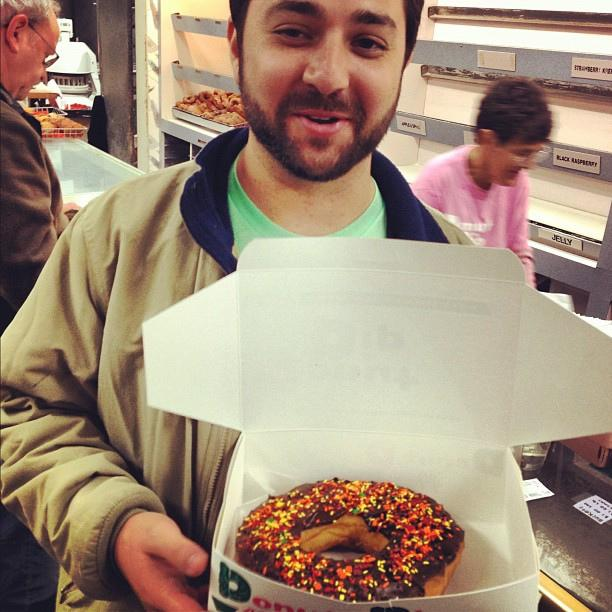What food nutrients are lacking in this food?

Choices:
A) starches
B) fiber
C) sugars
D) carbohydrates fiber 